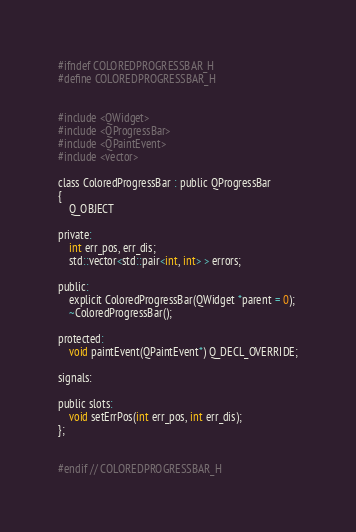Convert code to text. <code><loc_0><loc_0><loc_500><loc_500><_C_>#ifndef COLOREDPROGRESSBAR_H
#define COLOREDPROGRESSBAR_H


#include <QWidget>
#include <QProgressBar>
#include <QPaintEvent>
#include <vector>

class ColoredProgressBar : public QProgressBar
{
    Q_OBJECT

private:
    int err_pos, err_dis;
    std::vector<std::pair<int, int> > errors;

public:
    explicit ColoredProgressBar(QWidget *parent = 0);
    ~ColoredProgressBar();

protected:
    void paintEvent(QPaintEvent*) Q_DECL_OVERRIDE;

signals:

public slots:
    void setErrPos(int err_pos, int err_dis);
};


#endif // COLOREDPROGRESSBAR_H
</code> 